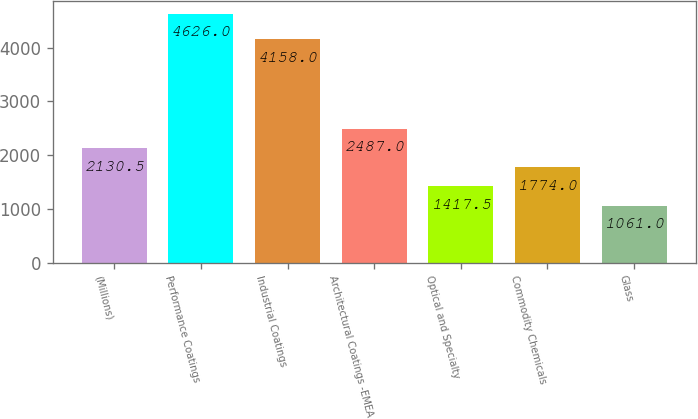Convert chart to OTSL. <chart><loc_0><loc_0><loc_500><loc_500><bar_chart><fcel>(Millions)<fcel>Performance Coatings<fcel>Industrial Coatings<fcel>Architectural Coatings -EMEA<fcel>Optical and Specialty<fcel>Commodity Chemicals<fcel>Glass<nl><fcel>2130.5<fcel>4626<fcel>4158<fcel>2487<fcel>1417.5<fcel>1774<fcel>1061<nl></chart> 